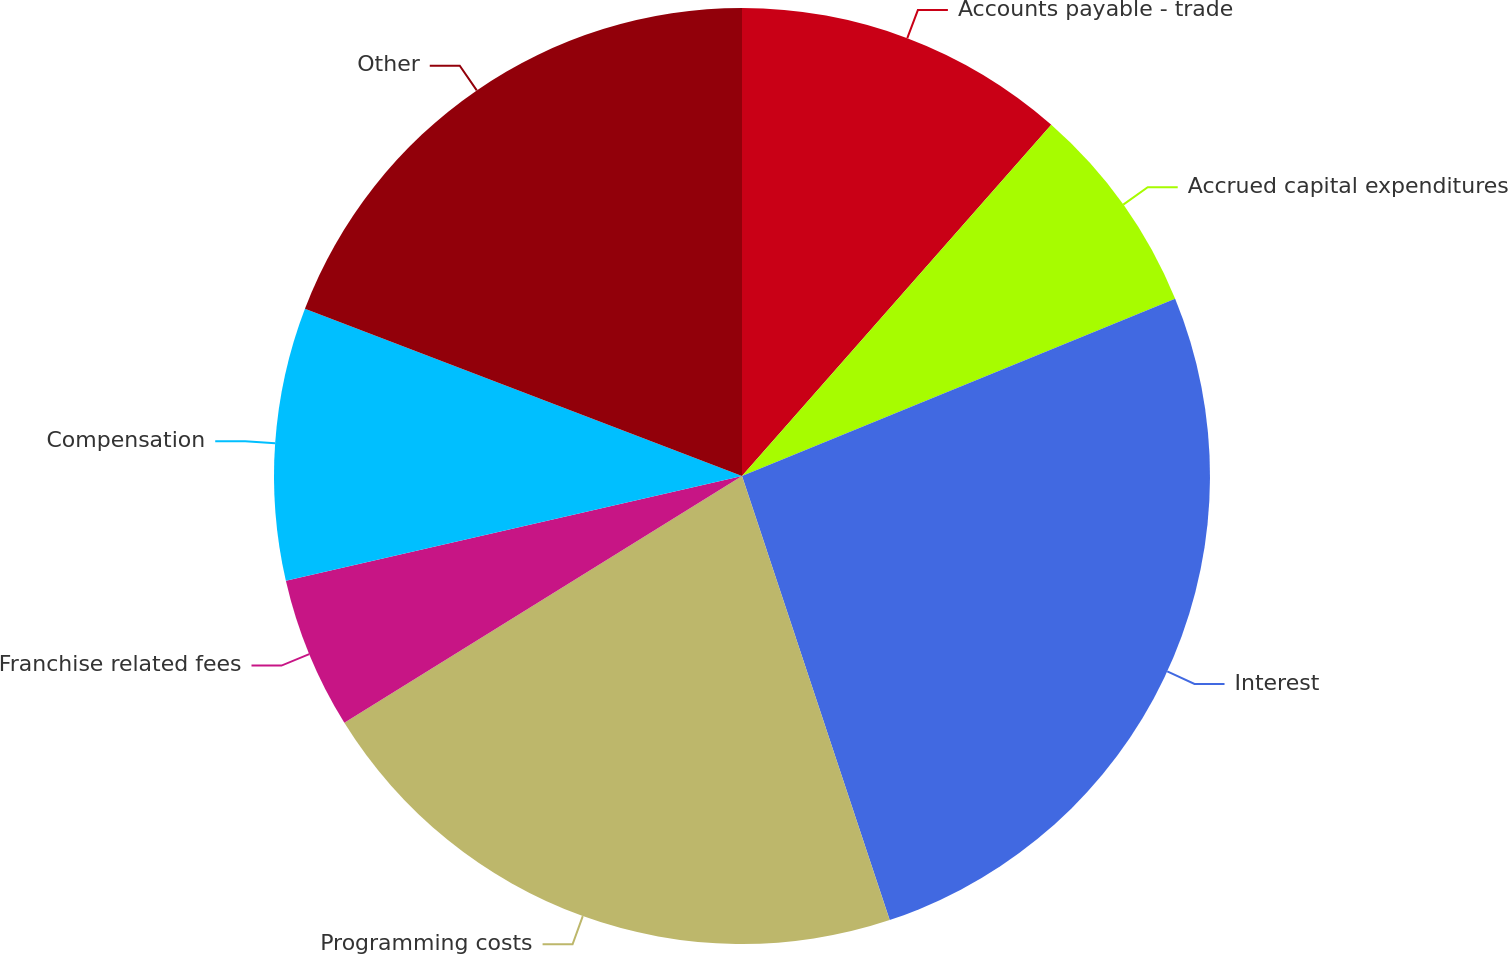<chart> <loc_0><loc_0><loc_500><loc_500><pie_chart><fcel>Accounts payable - trade<fcel>Accrued capital expenditures<fcel>Interest<fcel>Programming costs<fcel>Franchise related fees<fcel>Compensation<fcel>Other<nl><fcel>11.49%<fcel>7.33%<fcel>26.07%<fcel>21.27%<fcel>5.25%<fcel>9.41%<fcel>19.18%<nl></chart> 